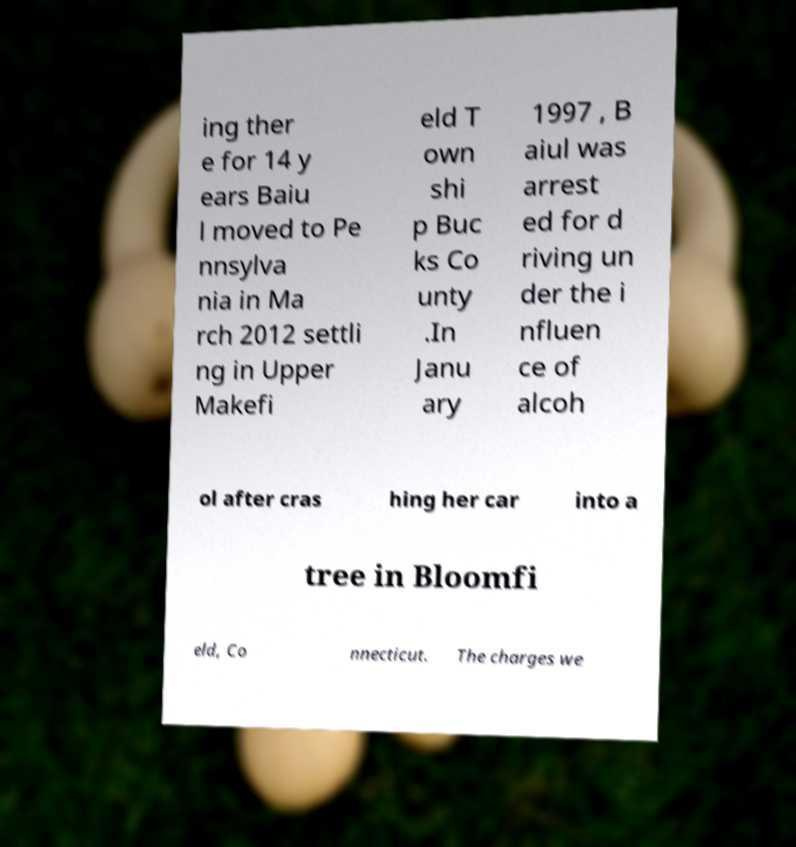I need the written content from this picture converted into text. Can you do that? ing ther e for 14 y ears Baiu l moved to Pe nnsylva nia in Ma rch 2012 settli ng in Upper Makefi eld T own shi p Buc ks Co unty .In Janu ary 1997 , B aiul was arrest ed for d riving un der the i nfluen ce of alcoh ol after cras hing her car into a tree in Bloomfi eld, Co nnecticut. The charges we 